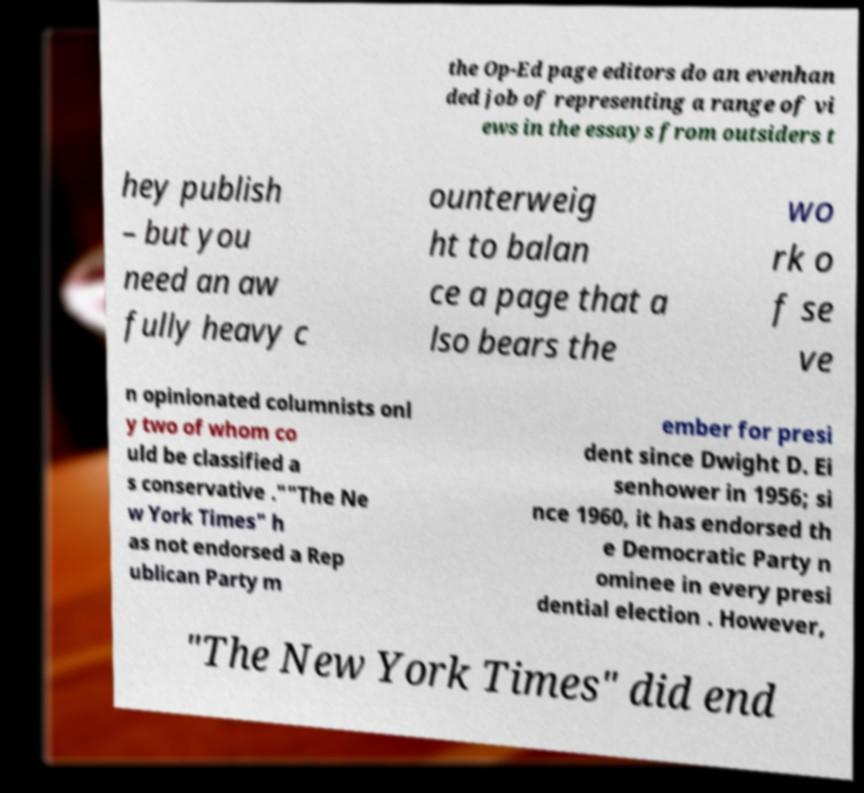Can you accurately transcribe the text from the provided image for me? the Op-Ed page editors do an evenhan ded job of representing a range of vi ews in the essays from outsiders t hey publish – but you need an aw fully heavy c ounterweig ht to balan ce a page that a lso bears the wo rk o f se ve n opinionated columnists onl y two of whom co uld be classified a s conservative .""The Ne w York Times" h as not endorsed a Rep ublican Party m ember for presi dent since Dwight D. Ei senhower in 1956; si nce 1960, it has endorsed th e Democratic Party n ominee in every presi dential election . However, "The New York Times" did end 